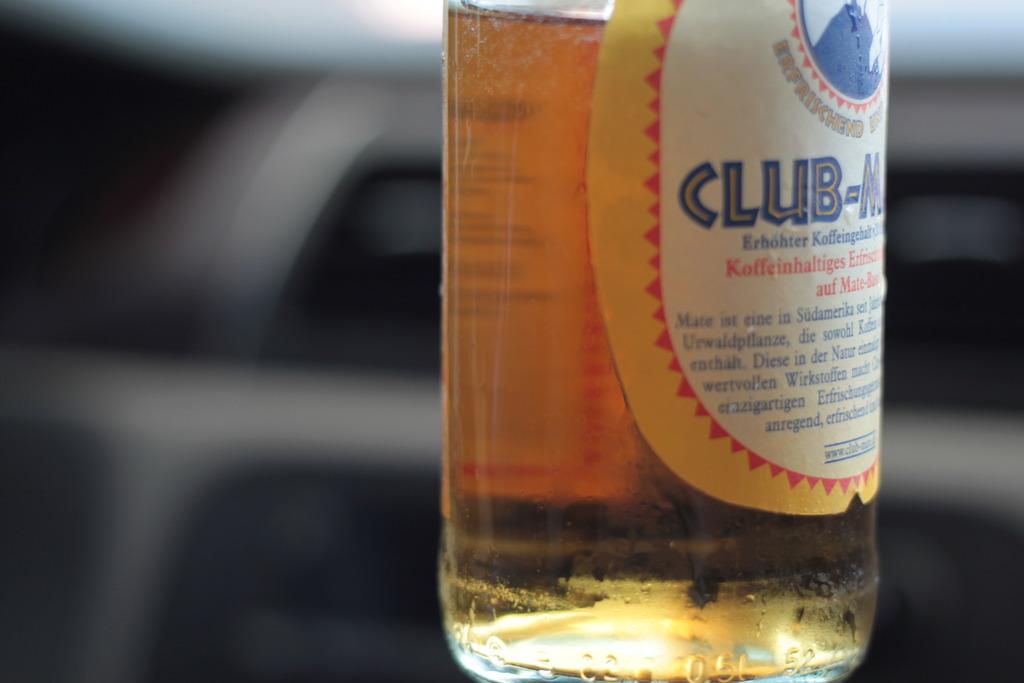What is the word written in blue?
Provide a succinct answer. Club. Is this a malt beverage or spirit?
Give a very brief answer. Malt. 